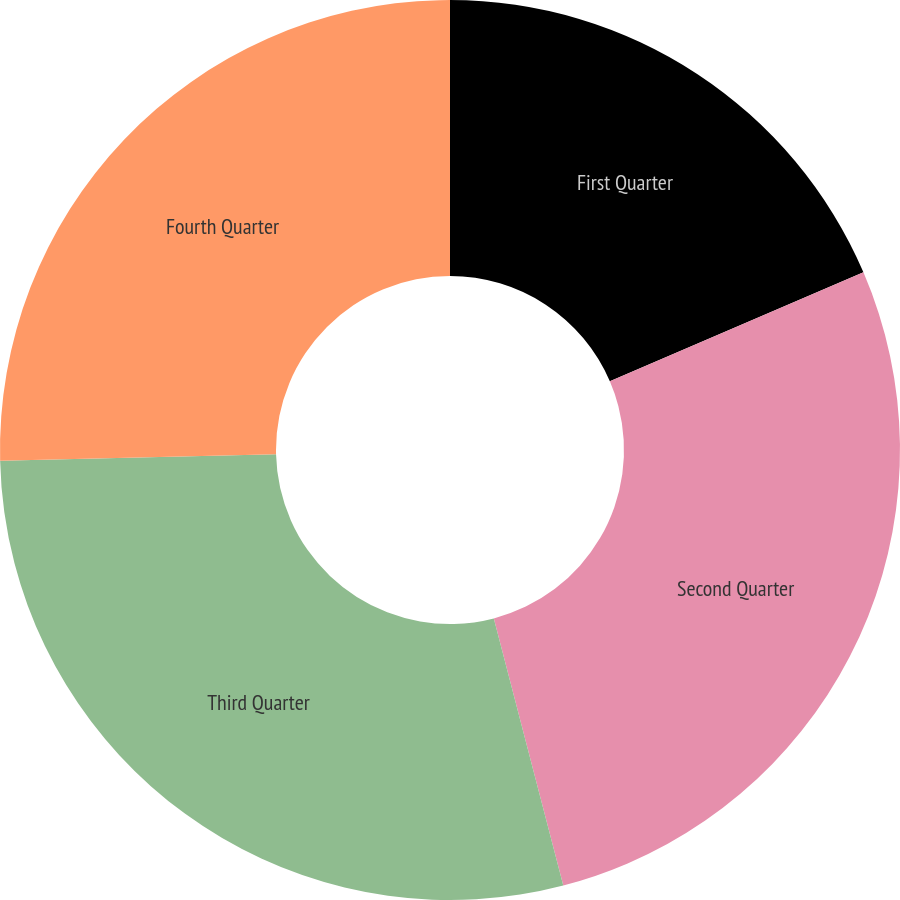Convert chart to OTSL. <chart><loc_0><loc_0><loc_500><loc_500><pie_chart><fcel>First Quarter<fcel>Second Quarter<fcel>Third Quarter<fcel>Fourth Quarter<nl><fcel>18.54%<fcel>27.41%<fcel>28.67%<fcel>25.38%<nl></chart> 